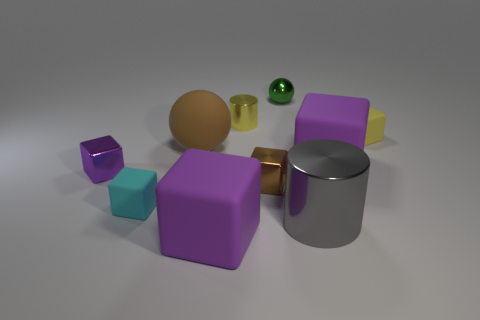Subtract all purple cubes. How many were subtracted if there are1purple cubes left? 2 Subtract all gray cylinders. How many purple blocks are left? 3 Subtract all cyan blocks. How many blocks are left? 5 Subtract all brown shiny blocks. How many blocks are left? 5 Subtract all brown blocks. Subtract all red cylinders. How many blocks are left? 5 Subtract all balls. How many objects are left? 8 Subtract 0 red balls. How many objects are left? 10 Subtract all tiny metallic objects. Subtract all tiny blocks. How many objects are left? 2 Add 9 brown balls. How many brown balls are left? 10 Add 7 metallic blocks. How many metallic blocks exist? 9 